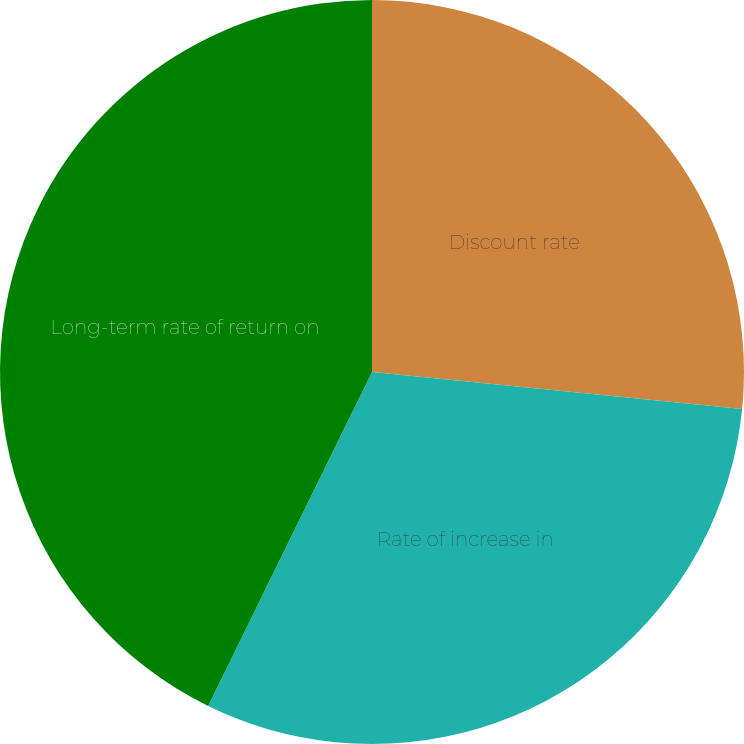<chart> <loc_0><loc_0><loc_500><loc_500><pie_chart><fcel>Discount rate<fcel>Rate of increase in<fcel>Long-term rate of return on<nl><fcel>26.59%<fcel>30.67%<fcel>42.74%<nl></chart> 